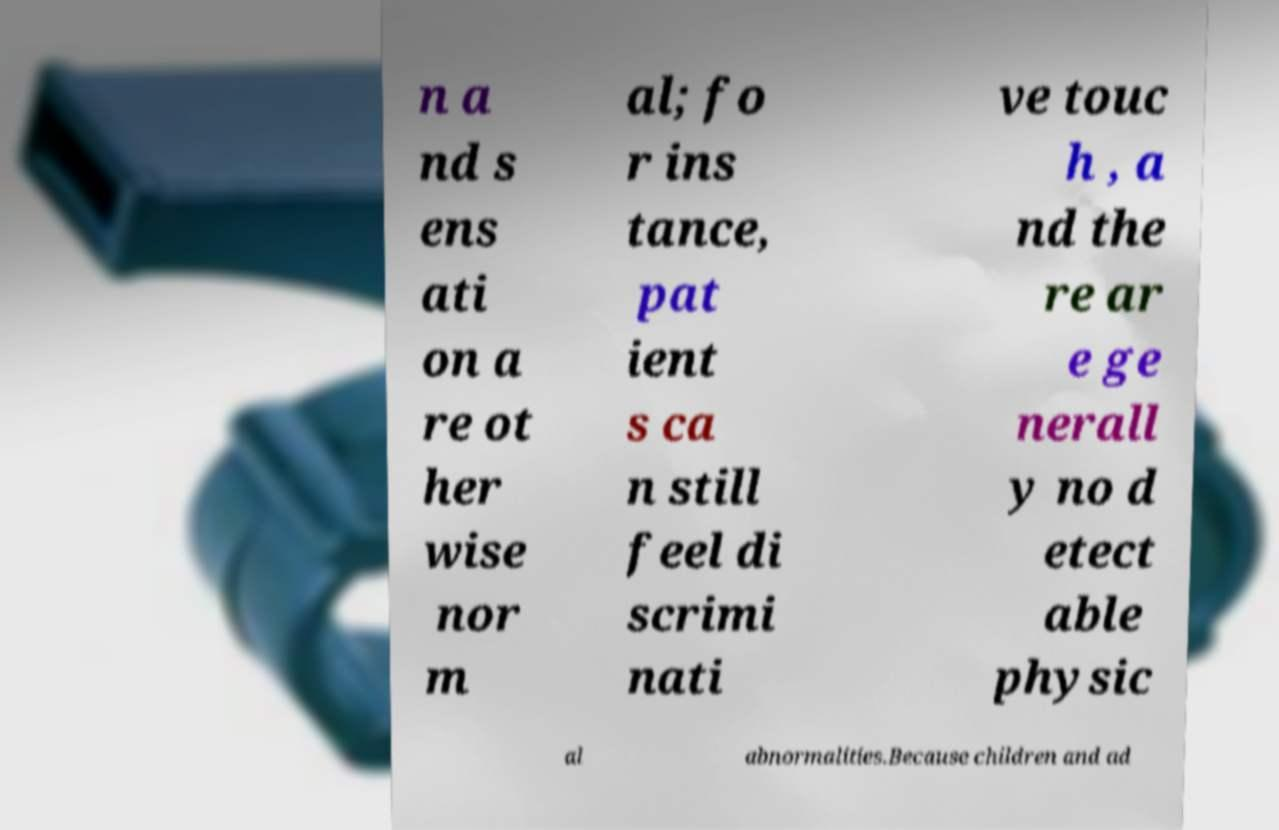What messages or text are displayed in this image? I need them in a readable, typed format. n a nd s ens ati on a re ot her wise nor m al; fo r ins tance, pat ient s ca n still feel di scrimi nati ve touc h , a nd the re ar e ge nerall y no d etect able physic al abnormalities.Because children and ad 